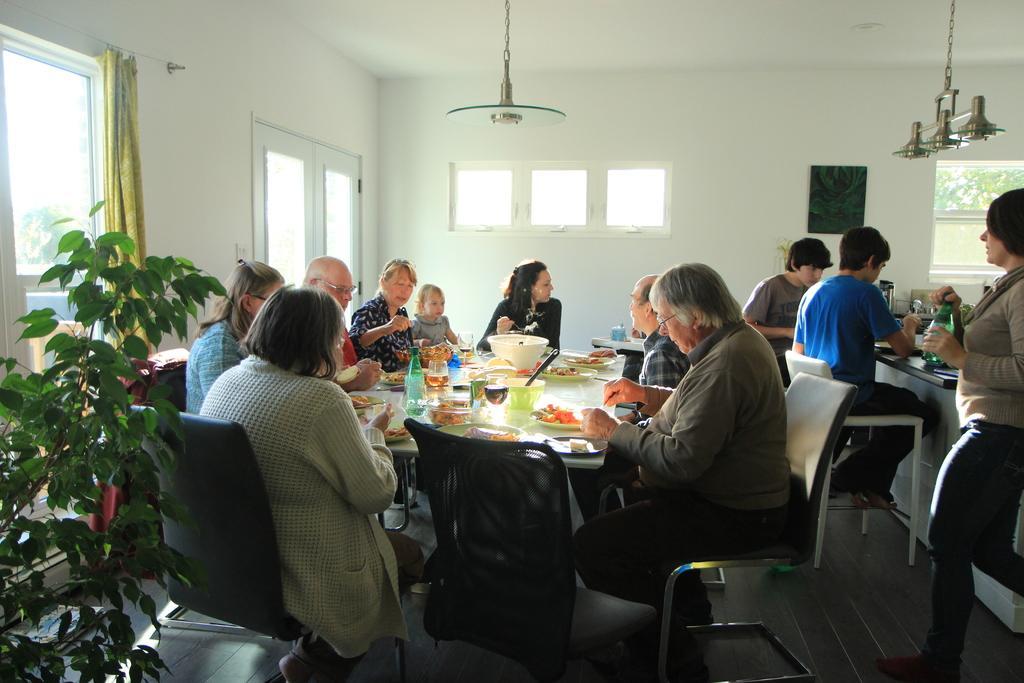Can you describe this image briefly? In this image i can see few persons sitting on chair there are few eatable items on the table at the back ground i can see a wall, window, curtain, a small plant. 